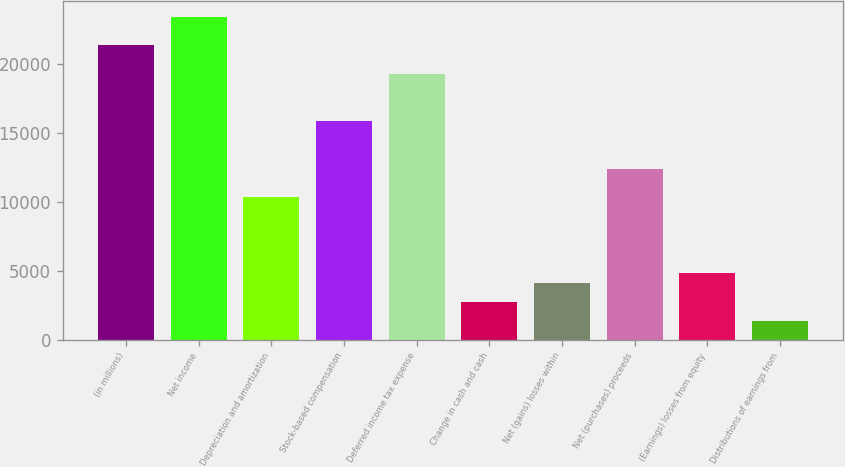Convert chart. <chart><loc_0><loc_0><loc_500><loc_500><bar_chart><fcel>(in millions)<fcel>Net income<fcel>Depreciation and amortization<fcel>Stock-based compensation<fcel>Deferred income tax expense<fcel>Change in cash and cash<fcel>Net (gains) losses within<fcel>Net (purchases) proceeds<fcel>(Earnings) losses from equity<fcel>Distributions of earnings from<nl><fcel>21354.6<fcel>23420.4<fcel>10337<fcel>15845.8<fcel>19288.8<fcel>2762.4<fcel>4139.6<fcel>12402.8<fcel>4828.2<fcel>1385.2<nl></chart> 